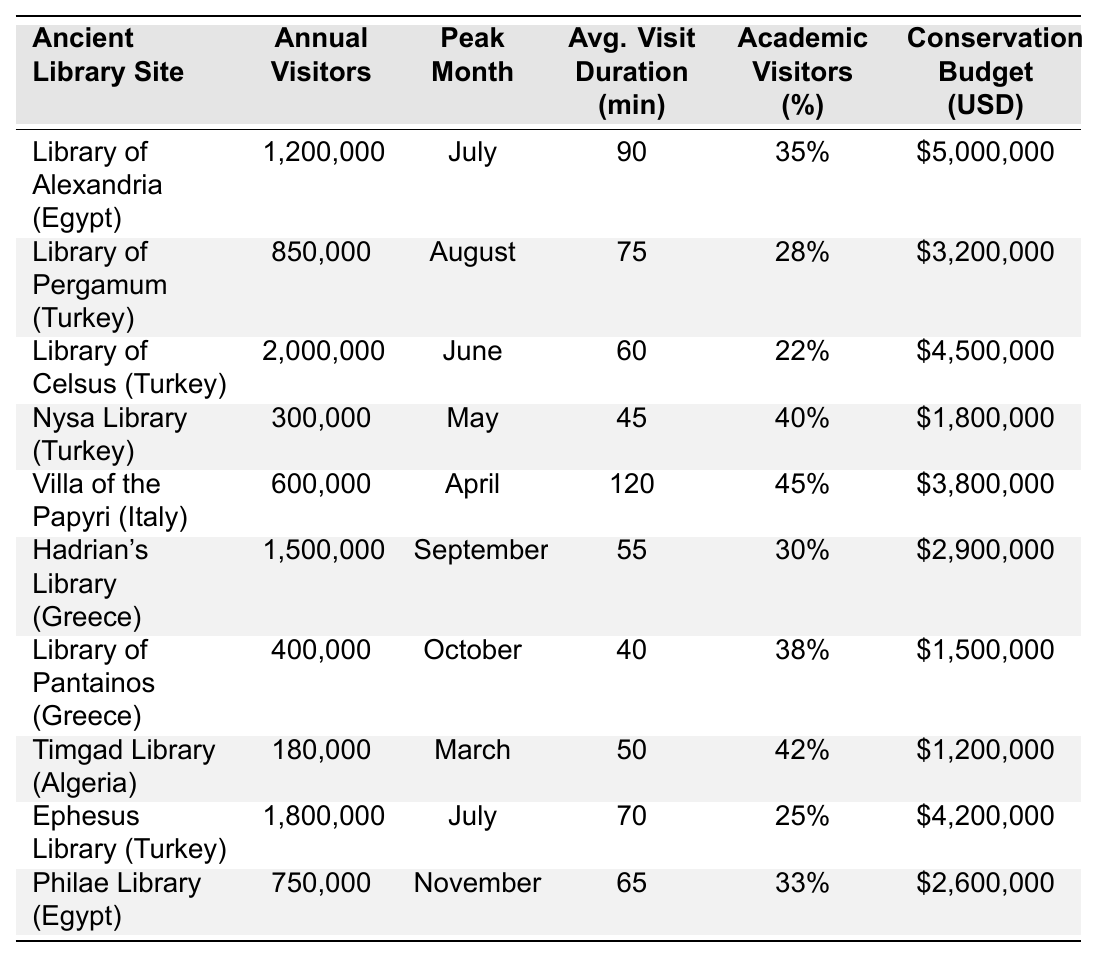What is the annual visitor count for the Library of Celsus? According to the table, the Library of Celsus has an annual visitor count of 2,000,000.
Answer: 2,000,000 Which library has the highest percentage of academic visitors? Looking at the percentage of academic visitors column, the Nysa Library has the highest percentage at 40%.
Answer: Nysa Library What is the average visit duration for the Villa of the Papyri? The table indicates that the average visit duration at the Villa of the Papyri is 120 minutes.
Answer: 120 minutes What is the total annual visitor count for all the libraries listed? The total is calculated by adding all the annual visitor counts: 1,200,000 + 850,000 + 2,000,000 + 300,000 + 600,000 + 1,500,000 + 400,000 + 180,000 + 1,800,000 + 750,000 = 9,280,000.
Answer: 9,280,000 Which library has the lowest conservation budget, and what is that amount? The Timgad Library has the lowest conservation budget of $1,200,000, as seen in the budget column.
Answer: Timgad Library, $1,200,000 Is the peak month for the Library of Pergamum August? Yes, the table states that the peak month for the Library of Pergamum is indeed August.
Answer: Yes What is the difference in annual visitors between the Library of Alexandria and the Ephesus Library? The difference is calculated by subtracting the annual visitors for Ephesus Library (1,800,000) from the Library of Alexandria (1,200,000), resulting in -600,000. This shows Ephesus Library has 600,000 more visitors.
Answer: 600,000 more visitors for Ephesus Library Which library has the longest average visit duration and what is that duration? The Villa of the Papyri has the longest average visit duration at 120 minutes, as stated in the duration column.
Answer: 120 minutes If you were to average the annual visitors from the libraries in Turkey, what would that be? The libraries in Turkey are the Library of Pergamum, Library of Celsus, Nysa Library, and Ephesus Library. Their annual visitors are 850,000, 2,000,000, 300,000, and 1,800,000 respectively. The total is 850,000 + 2,000,000 + 300,000 + 1,800,000 = 4,950,000. Dividing by the number of libraries (4) gives an average of 1,237,500.
Answer: 1,237,500 Which two libraries have similar average visit durations and what are those durations? The average visit durations for the Library of Celsus (60 minutes) and Hadrian's Library (55 minutes) are quite similar. A few others like the Library of Pantainos (40 minutes) and Timgad Library (50 minutes) also have close durations.
Answer: Celsus (60 mins) and Hadrian's (55 mins) are similar 